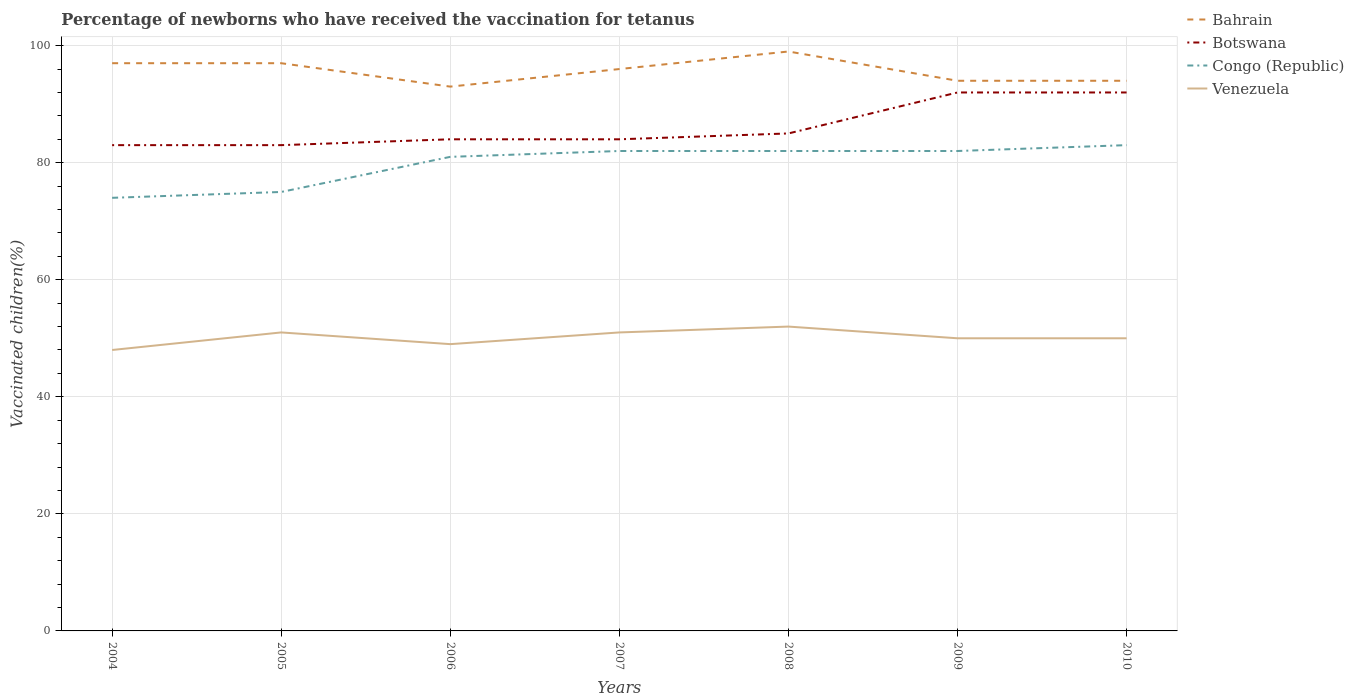Is the number of lines equal to the number of legend labels?
Offer a terse response. Yes. In which year was the percentage of vaccinated children in Venezuela maximum?
Give a very brief answer. 2004. What is the total percentage of vaccinated children in Congo (Republic) in the graph?
Make the answer very short. -8. What is the difference between the highest and the second highest percentage of vaccinated children in Botswana?
Offer a terse response. 9. How many lines are there?
Offer a terse response. 4. How many years are there in the graph?
Provide a short and direct response. 7. What is the difference between two consecutive major ticks on the Y-axis?
Provide a succinct answer. 20. Does the graph contain grids?
Your response must be concise. Yes. How many legend labels are there?
Ensure brevity in your answer.  4. What is the title of the graph?
Your response must be concise. Percentage of newborns who have received the vaccination for tetanus. What is the label or title of the X-axis?
Your response must be concise. Years. What is the label or title of the Y-axis?
Keep it short and to the point. Vaccinated children(%). What is the Vaccinated children(%) in Bahrain in 2004?
Provide a short and direct response. 97. What is the Vaccinated children(%) in Botswana in 2004?
Your answer should be compact. 83. What is the Vaccinated children(%) of Bahrain in 2005?
Ensure brevity in your answer.  97. What is the Vaccinated children(%) of Congo (Republic) in 2005?
Keep it short and to the point. 75. What is the Vaccinated children(%) of Bahrain in 2006?
Provide a succinct answer. 93. What is the Vaccinated children(%) of Congo (Republic) in 2006?
Make the answer very short. 81. What is the Vaccinated children(%) of Bahrain in 2007?
Your response must be concise. 96. What is the Vaccinated children(%) in Bahrain in 2008?
Your answer should be compact. 99. What is the Vaccinated children(%) of Botswana in 2008?
Give a very brief answer. 85. What is the Vaccinated children(%) in Bahrain in 2009?
Offer a terse response. 94. What is the Vaccinated children(%) in Botswana in 2009?
Give a very brief answer. 92. What is the Vaccinated children(%) in Congo (Republic) in 2009?
Make the answer very short. 82. What is the Vaccinated children(%) of Venezuela in 2009?
Offer a very short reply. 50. What is the Vaccinated children(%) of Bahrain in 2010?
Offer a terse response. 94. What is the Vaccinated children(%) of Botswana in 2010?
Provide a short and direct response. 92. Across all years, what is the maximum Vaccinated children(%) in Botswana?
Keep it short and to the point. 92. Across all years, what is the maximum Vaccinated children(%) in Congo (Republic)?
Offer a very short reply. 83. Across all years, what is the minimum Vaccinated children(%) of Bahrain?
Your answer should be compact. 93. Across all years, what is the minimum Vaccinated children(%) of Botswana?
Your response must be concise. 83. Across all years, what is the minimum Vaccinated children(%) of Venezuela?
Offer a very short reply. 48. What is the total Vaccinated children(%) in Bahrain in the graph?
Provide a succinct answer. 670. What is the total Vaccinated children(%) of Botswana in the graph?
Offer a very short reply. 603. What is the total Vaccinated children(%) of Congo (Republic) in the graph?
Offer a terse response. 559. What is the total Vaccinated children(%) of Venezuela in the graph?
Provide a succinct answer. 351. What is the difference between the Vaccinated children(%) of Congo (Republic) in 2004 and that in 2005?
Make the answer very short. -1. What is the difference between the Vaccinated children(%) of Venezuela in 2004 and that in 2006?
Ensure brevity in your answer.  -1. What is the difference between the Vaccinated children(%) in Venezuela in 2004 and that in 2007?
Your answer should be compact. -3. What is the difference between the Vaccinated children(%) in Botswana in 2004 and that in 2008?
Provide a short and direct response. -2. What is the difference between the Vaccinated children(%) in Venezuela in 2004 and that in 2008?
Your answer should be very brief. -4. What is the difference between the Vaccinated children(%) of Congo (Republic) in 2004 and that in 2009?
Ensure brevity in your answer.  -8. What is the difference between the Vaccinated children(%) of Botswana in 2004 and that in 2010?
Offer a very short reply. -9. What is the difference between the Vaccinated children(%) in Congo (Republic) in 2004 and that in 2010?
Make the answer very short. -9. What is the difference between the Vaccinated children(%) in Venezuela in 2004 and that in 2010?
Keep it short and to the point. -2. What is the difference between the Vaccinated children(%) of Congo (Republic) in 2005 and that in 2006?
Your response must be concise. -6. What is the difference between the Vaccinated children(%) in Bahrain in 2005 and that in 2007?
Ensure brevity in your answer.  1. What is the difference between the Vaccinated children(%) in Venezuela in 2005 and that in 2007?
Ensure brevity in your answer.  0. What is the difference between the Vaccinated children(%) of Botswana in 2005 and that in 2008?
Keep it short and to the point. -2. What is the difference between the Vaccinated children(%) in Congo (Republic) in 2005 and that in 2008?
Ensure brevity in your answer.  -7. What is the difference between the Vaccinated children(%) in Venezuela in 2005 and that in 2008?
Keep it short and to the point. -1. What is the difference between the Vaccinated children(%) of Bahrain in 2005 and that in 2009?
Your answer should be very brief. 3. What is the difference between the Vaccinated children(%) in Botswana in 2005 and that in 2009?
Your answer should be compact. -9. What is the difference between the Vaccinated children(%) of Bahrain in 2005 and that in 2010?
Offer a terse response. 3. What is the difference between the Vaccinated children(%) in Botswana in 2005 and that in 2010?
Make the answer very short. -9. What is the difference between the Vaccinated children(%) in Venezuela in 2005 and that in 2010?
Offer a very short reply. 1. What is the difference between the Vaccinated children(%) in Bahrain in 2006 and that in 2007?
Offer a terse response. -3. What is the difference between the Vaccinated children(%) in Botswana in 2006 and that in 2007?
Your answer should be very brief. 0. What is the difference between the Vaccinated children(%) in Venezuela in 2006 and that in 2007?
Offer a terse response. -2. What is the difference between the Vaccinated children(%) of Bahrain in 2006 and that in 2008?
Your answer should be very brief. -6. What is the difference between the Vaccinated children(%) of Venezuela in 2006 and that in 2009?
Your response must be concise. -1. What is the difference between the Vaccinated children(%) in Bahrain in 2006 and that in 2010?
Offer a very short reply. -1. What is the difference between the Vaccinated children(%) in Bahrain in 2007 and that in 2008?
Your answer should be compact. -3. What is the difference between the Vaccinated children(%) in Botswana in 2007 and that in 2008?
Your answer should be compact. -1. What is the difference between the Vaccinated children(%) of Congo (Republic) in 2007 and that in 2008?
Offer a terse response. 0. What is the difference between the Vaccinated children(%) in Venezuela in 2007 and that in 2008?
Make the answer very short. -1. What is the difference between the Vaccinated children(%) of Bahrain in 2007 and that in 2009?
Your response must be concise. 2. What is the difference between the Vaccinated children(%) in Congo (Republic) in 2007 and that in 2009?
Your answer should be very brief. 0. What is the difference between the Vaccinated children(%) of Bahrain in 2007 and that in 2010?
Provide a short and direct response. 2. What is the difference between the Vaccinated children(%) in Botswana in 2007 and that in 2010?
Your response must be concise. -8. What is the difference between the Vaccinated children(%) in Congo (Republic) in 2007 and that in 2010?
Make the answer very short. -1. What is the difference between the Vaccinated children(%) of Venezuela in 2007 and that in 2010?
Provide a short and direct response. 1. What is the difference between the Vaccinated children(%) of Venezuela in 2008 and that in 2009?
Ensure brevity in your answer.  2. What is the difference between the Vaccinated children(%) in Bahrain in 2008 and that in 2010?
Your response must be concise. 5. What is the difference between the Vaccinated children(%) of Botswana in 2008 and that in 2010?
Your answer should be very brief. -7. What is the difference between the Vaccinated children(%) of Botswana in 2009 and that in 2010?
Offer a terse response. 0. What is the difference between the Vaccinated children(%) of Congo (Republic) in 2009 and that in 2010?
Your answer should be compact. -1. What is the difference between the Vaccinated children(%) of Venezuela in 2009 and that in 2010?
Ensure brevity in your answer.  0. What is the difference between the Vaccinated children(%) in Bahrain in 2004 and the Vaccinated children(%) in Botswana in 2005?
Ensure brevity in your answer.  14. What is the difference between the Vaccinated children(%) of Bahrain in 2004 and the Vaccinated children(%) of Congo (Republic) in 2005?
Offer a very short reply. 22. What is the difference between the Vaccinated children(%) in Bahrain in 2004 and the Vaccinated children(%) in Botswana in 2006?
Your answer should be very brief. 13. What is the difference between the Vaccinated children(%) of Bahrain in 2004 and the Vaccinated children(%) of Venezuela in 2006?
Make the answer very short. 48. What is the difference between the Vaccinated children(%) in Botswana in 2004 and the Vaccinated children(%) in Congo (Republic) in 2006?
Give a very brief answer. 2. What is the difference between the Vaccinated children(%) of Congo (Republic) in 2004 and the Vaccinated children(%) of Venezuela in 2006?
Your answer should be very brief. 25. What is the difference between the Vaccinated children(%) in Bahrain in 2004 and the Vaccinated children(%) in Venezuela in 2007?
Provide a succinct answer. 46. What is the difference between the Vaccinated children(%) of Botswana in 2004 and the Vaccinated children(%) of Venezuela in 2007?
Your response must be concise. 32. What is the difference between the Vaccinated children(%) of Congo (Republic) in 2004 and the Vaccinated children(%) of Venezuela in 2007?
Offer a terse response. 23. What is the difference between the Vaccinated children(%) in Bahrain in 2004 and the Vaccinated children(%) in Botswana in 2008?
Keep it short and to the point. 12. What is the difference between the Vaccinated children(%) in Bahrain in 2004 and the Vaccinated children(%) in Congo (Republic) in 2008?
Offer a very short reply. 15. What is the difference between the Vaccinated children(%) of Bahrain in 2004 and the Vaccinated children(%) of Venezuela in 2008?
Make the answer very short. 45. What is the difference between the Vaccinated children(%) of Botswana in 2004 and the Vaccinated children(%) of Venezuela in 2008?
Your answer should be compact. 31. What is the difference between the Vaccinated children(%) in Bahrain in 2004 and the Vaccinated children(%) in Botswana in 2009?
Make the answer very short. 5. What is the difference between the Vaccinated children(%) in Bahrain in 2004 and the Vaccinated children(%) in Congo (Republic) in 2009?
Your response must be concise. 15. What is the difference between the Vaccinated children(%) of Congo (Republic) in 2004 and the Vaccinated children(%) of Venezuela in 2009?
Make the answer very short. 24. What is the difference between the Vaccinated children(%) in Botswana in 2004 and the Vaccinated children(%) in Congo (Republic) in 2010?
Keep it short and to the point. 0. What is the difference between the Vaccinated children(%) in Bahrain in 2005 and the Vaccinated children(%) in Botswana in 2007?
Give a very brief answer. 13. What is the difference between the Vaccinated children(%) of Bahrain in 2005 and the Vaccinated children(%) of Venezuela in 2007?
Your answer should be compact. 46. What is the difference between the Vaccinated children(%) in Botswana in 2005 and the Vaccinated children(%) in Congo (Republic) in 2007?
Offer a very short reply. 1. What is the difference between the Vaccinated children(%) in Bahrain in 2005 and the Vaccinated children(%) in Venezuela in 2008?
Make the answer very short. 45. What is the difference between the Vaccinated children(%) in Botswana in 2005 and the Vaccinated children(%) in Congo (Republic) in 2008?
Give a very brief answer. 1. What is the difference between the Vaccinated children(%) of Bahrain in 2005 and the Vaccinated children(%) of Venezuela in 2009?
Ensure brevity in your answer.  47. What is the difference between the Vaccinated children(%) in Botswana in 2005 and the Vaccinated children(%) in Venezuela in 2009?
Your answer should be compact. 33. What is the difference between the Vaccinated children(%) of Congo (Republic) in 2005 and the Vaccinated children(%) of Venezuela in 2009?
Provide a short and direct response. 25. What is the difference between the Vaccinated children(%) in Bahrain in 2005 and the Vaccinated children(%) in Congo (Republic) in 2010?
Give a very brief answer. 14. What is the difference between the Vaccinated children(%) of Botswana in 2005 and the Vaccinated children(%) of Congo (Republic) in 2010?
Provide a short and direct response. 0. What is the difference between the Vaccinated children(%) of Bahrain in 2006 and the Vaccinated children(%) of Botswana in 2007?
Provide a short and direct response. 9. What is the difference between the Vaccinated children(%) in Bahrain in 2006 and the Vaccinated children(%) in Congo (Republic) in 2007?
Make the answer very short. 11. What is the difference between the Vaccinated children(%) in Bahrain in 2006 and the Vaccinated children(%) in Venezuela in 2007?
Offer a terse response. 42. What is the difference between the Vaccinated children(%) in Bahrain in 2006 and the Vaccinated children(%) in Botswana in 2008?
Your answer should be very brief. 8. What is the difference between the Vaccinated children(%) of Bahrain in 2006 and the Vaccinated children(%) of Venezuela in 2008?
Provide a succinct answer. 41. What is the difference between the Vaccinated children(%) in Botswana in 2006 and the Vaccinated children(%) in Congo (Republic) in 2008?
Keep it short and to the point. 2. What is the difference between the Vaccinated children(%) of Bahrain in 2006 and the Vaccinated children(%) of Botswana in 2009?
Provide a short and direct response. 1. What is the difference between the Vaccinated children(%) of Botswana in 2006 and the Vaccinated children(%) of Congo (Republic) in 2009?
Provide a short and direct response. 2. What is the difference between the Vaccinated children(%) in Botswana in 2006 and the Vaccinated children(%) in Venezuela in 2009?
Keep it short and to the point. 34. What is the difference between the Vaccinated children(%) of Congo (Republic) in 2006 and the Vaccinated children(%) of Venezuela in 2009?
Give a very brief answer. 31. What is the difference between the Vaccinated children(%) in Bahrain in 2006 and the Vaccinated children(%) in Botswana in 2010?
Keep it short and to the point. 1. What is the difference between the Vaccinated children(%) in Bahrain in 2006 and the Vaccinated children(%) in Congo (Republic) in 2010?
Your answer should be very brief. 10. What is the difference between the Vaccinated children(%) of Bahrain in 2006 and the Vaccinated children(%) of Venezuela in 2010?
Your answer should be compact. 43. What is the difference between the Vaccinated children(%) of Botswana in 2006 and the Vaccinated children(%) of Venezuela in 2010?
Your answer should be very brief. 34. What is the difference between the Vaccinated children(%) of Congo (Republic) in 2006 and the Vaccinated children(%) of Venezuela in 2010?
Ensure brevity in your answer.  31. What is the difference between the Vaccinated children(%) in Botswana in 2007 and the Vaccinated children(%) in Venezuela in 2008?
Provide a succinct answer. 32. What is the difference between the Vaccinated children(%) in Congo (Republic) in 2007 and the Vaccinated children(%) in Venezuela in 2008?
Provide a succinct answer. 30. What is the difference between the Vaccinated children(%) in Bahrain in 2007 and the Vaccinated children(%) in Botswana in 2009?
Your answer should be very brief. 4. What is the difference between the Vaccinated children(%) of Bahrain in 2007 and the Vaccinated children(%) of Congo (Republic) in 2009?
Give a very brief answer. 14. What is the difference between the Vaccinated children(%) of Bahrain in 2007 and the Vaccinated children(%) of Venezuela in 2009?
Offer a very short reply. 46. What is the difference between the Vaccinated children(%) in Bahrain in 2007 and the Vaccinated children(%) in Congo (Republic) in 2010?
Give a very brief answer. 13. What is the difference between the Vaccinated children(%) in Bahrain in 2007 and the Vaccinated children(%) in Venezuela in 2010?
Your answer should be very brief. 46. What is the difference between the Vaccinated children(%) of Botswana in 2007 and the Vaccinated children(%) of Congo (Republic) in 2010?
Your response must be concise. 1. What is the difference between the Vaccinated children(%) of Congo (Republic) in 2007 and the Vaccinated children(%) of Venezuela in 2010?
Your answer should be very brief. 32. What is the difference between the Vaccinated children(%) of Bahrain in 2008 and the Vaccinated children(%) of Botswana in 2009?
Offer a very short reply. 7. What is the difference between the Vaccinated children(%) in Bahrain in 2008 and the Vaccinated children(%) in Venezuela in 2009?
Make the answer very short. 49. What is the difference between the Vaccinated children(%) of Botswana in 2008 and the Vaccinated children(%) of Congo (Republic) in 2009?
Ensure brevity in your answer.  3. What is the difference between the Vaccinated children(%) in Bahrain in 2008 and the Vaccinated children(%) in Congo (Republic) in 2010?
Offer a terse response. 16. What is the difference between the Vaccinated children(%) in Bahrain in 2008 and the Vaccinated children(%) in Venezuela in 2010?
Provide a short and direct response. 49. What is the difference between the Vaccinated children(%) of Botswana in 2008 and the Vaccinated children(%) of Congo (Republic) in 2010?
Offer a terse response. 2. What is the difference between the Vaccinated children(%) in Botswana in 2008 and the Vaccinated children(%) in Venezuela in 2010?
Your answer should be very brief. 35. What is the difference between the Vaccinated children(%) in Congo (Republic) in 2008 and the Vaccinated children(%) in Venezuela in 2010?
Offer a terse response. 32. What is the difference between the Vaccinated children(%) in Bahrain in 2009 and the Vaccinated children(%) in Botswana in 2010?
Provide a short and direct response. 2. What is the difference between the Vaccinated children(%) in Bahrain in 2009 and the Vaccinated children(%) in Venezuela in 2010?
Your answer should be compact. 44. What is the difference between the Vaccinated children(%) of Botswana in 2009 and the Vaccinated children(%) of Congo (Republic) in 2010?
Ensure brevity in your answer.  9. What is the difference between the Vaccinated children(%) of Botswana in 2009 and the Vaccinated children(%) of Venezuela in 2010?
Keep it short and to the point. 42. What is the average Vaccinated children(%) in Bahrain per year?
Provide a succinct answer. 95.71. What is the average Vaccinated children(%) of Botswana per year?
Give a very brief answer. 86.14. What is the average Vaccinated children(%) of Congo (Republic) per year?
Ensure brevity in your answer.  79.86. What is the average Vaccinated children(%) in Venezuela per year?
Provide a succinct answer. 50.14. In the year 2004, what is the difference between the Vaccinated children(%) in Bahrain and Vaccinated children(%) in Congo (Republic)?
Offer a very short reply. 23. In the year 2004, what is the difference between the Vaccinated children(%) in Botswana and Vaccinated children(%) in Congo (Republic)?
Give a very brief answer. 9. In the year 2005, what is the difference between the Vaccinated children(%) in Bahrain and Vaccinated children(%) in Botswana?
Give a very brief answer. 14. In the year 2005, what is the difference between the Vaccinated children(%) in Bahrain and Vaccinated children(%) in Congo (Republic)?
Ensure brevity in your answer.  22. In the year 2005, what is the difference between the Vaccinated children(%) of Bahrain and Vaccinated children(%) of Venezuela?
Your answer should be very brief. 46. In the year 2005, what is the difference between the Vaccinated children(%) of Congo (Republic) and Vaccinated children(%) of Venezuela?
Provide a short and direct response. 24. In the year 2006, what is the difference between the Vaccinated children(%) of Bahrain and Vaccinated children(%) of Botswana?
Your response must be concise. 9. In the year 2006, what is the difference between the Vaccinated children(%) in Bahrain and Vaccinated children(%) in Venezuela?
Keep it short and to the point. 44. In the year 2006, what is the difference between the Vaccinated children(%) in Botswana and Vaccinated children(%) in Congo (Republic)?
Ensure brevity in your answer.  3. In the year 2006, what is the difference between the Vaccinated children(%) of Botswana and Vaccinated children(%) of Venezuela?
Make the answer very short. 35. In the year 2006, what is the difference between the Vaccinated children(%) of Congo (Republic) and Vaccinated children(%) of Venezuela?
Give a very brief answer. 32. In the year 2007, what is the difference between the Vaccinated children(%) of Bahrain and Vaccinated children(%) of Botswana?
Your answer should be compact. 12. In the year 2007, what is the difference between the Vaccinated children(%) of Bahrain and Vaccinated children(%) of Congo (Republic)?
Keep it short and to the point. 14. In the year 2007, what is the difference between the Vaccinated children(%) of Bahrain and Vaccinated children(%) of Venezuela?
Make the answer very short. 45. In the year 2007, what is the difference between the Vaccinated children(%) in Congo (Republic) and Vaccinated children(%) in Venezuela?
Offer a terse response. 31. In the year 2008, what is the difference between the Vaccinated children(%) in Bahrain and Vaccinated children(%) in Botswana?
Keep it short and to the point. 14. In the year 2008, what is the difference between the Vaccinated children(%) of Bahrain and Vaccinated children(%) of Congo (Republic)?
Your answer should be very brief. 17. In the year 2008, what is the difference between the Vaccinated children(%) of Bahrain and Vaccinated children(%) of Venezuela?
Your answer should be very brief. 47. In the year 2008, what is the difference between the Vaccinated children(%) in Botswana and Vaccinated children(%) in Congo (Republic)?
Ensure brevity in your answer.  3. In the year 2008, what is the difference between the Vaccinated children(%) of Botswana and Vaccinated children(%) of Venezuela?
Offer a terse response. 33. In the year 2009, what is the difference between the Vaccinated children(%) of Botswana and Vaccinated children(%) of Congo (Republic)?
Your answer should be very brief. 10. In the year 2009, what is the difference between the Vaccinated children(%) of Congo (Republic) and Vaccinated children(%) of Venezuela?
Offer a very short reply. 32. In the year 2010, what is the difference between the Vaccinated children(%) in Bahrain and Vaccinated children(%) in Botswana?
Your response must be concise. 2. In the year 2010, what is the difference between the Vaccinated children(%) of Bahrain and Vaccinated children(%) of Venezuela?
Your answer should be compact. 44. What is the ratio of the Vaccinated children(%) of Bahrain in 2004 to that in 2005?
Offer a very short reply. 1. What is the ratio of the Vaccinated children(%) of Congo (Republic) in 2004 to that in 2005?
Your answer should be compact. 0.99. What is the ratio of the Vaccinated children(%) of Bahrain in 2004 to that in 2006?
Make the answer very short. 1.04. What is the ratio of the Vaccinated children(%) in Congo (Republic) in 2004 to that in 2006?
Offer a very short reply. 0.91. What is the ratio of the Vaccinated children(%) of Venezuela in 2004 to that in 2006?
Provide a succinct answer. 0.98. What is the ratio of the Vaccinated children(%) in Bahrain in 2004 to that in 2007?
Offer a terse response. 1.01. What is the ratio of the Vaccinated children(%) of Congo (Republic) in 2004 to that in 2007?
Provide a succinct answer. 0.9. What is the ratio of the Vaccinated children(%) in Venezuela in 2004 to that in 2007?
Give a very brief answer. 0.94. What is the ratio of the Vaccinated children(%) of Bahrain in 2004 to that in 2008?
Your response must be concise. 0.98. What is the ratio of the Vaccinated children(%) of Botswana in 2004 to that in 2008?
Your answer should be very brief. 0.98. What is the ratio of the Vaccinated children(%) in Congo (Republic) in 2004 to that in 2008?
Provide a succinct answer. 0.9. What is the ratio of the Vaccinated children(%) in Venezuela in 2004 to that in 2008?
Offer a terse response. 0.92. What is the ratio of the Vaccinated children(%) in Bahrain in 2004 to that in 2009?
Ensure brevity in your answer.  1.03. What is the ratio of the Vaccinated children(%) in Botswana in 2004 to that in 2009?
Make the answer very short. 0.9. What is the ratio of the Vaccinated children(%) in Congo (Republic) in 2004 to that in 2009?
Keep it short and to the point. 0.9. What is the ratio of the Vaccinated children(%) in Venezuela in 2004 to that in 2009?
Keep it short and to the point. 0.96. What is the ratio of the Vaccinated children(%) of Bahrain in 2004 to that in 2010?
Make the answer very short. 1.03. What is the ratio of the Vaccinated children(%) in Botswana in 2004 to that in 2010?
Your answer should be compact. 0.9. What is the ratio of the Vaccinated children(%) of Congo (Republic) in 2004 to that in 2010?
Offer a very short reply. 0.89. What is the ratio of the Vaccinated children(%) in Bahrain in 2005 to that in 2006?
Offer a very short reply. 1.04. What is the ratio of the Vaccinated children(%) of Botswana in 2005 to that in 2006?
Your response must be concise. 0.99. What is the ratio of the Vaccinated children(%) in Congo (Republic) in 2005 to that in 2006?
Offer a terse response. 0.93. What is the ratio of the Vaccinated children(%) of Venezuela in 2005 to that in 2006?
Give a very brief answer. 1.04. What is the ratio of the Vaccinated children(%) of Bahrain in 2005 to that in 2007?
Your response must be concise. 1.01. What is the ratio of the Vaccinated children(%) of Congo (Republic) in 2005 to that in 2007?
Your answer should be very brief. 0.91. What is the ratio of the Vaccinated children(%) in Bahrain in 2005 to that in 2008?
Provide a succinct answer. 0.98. What is the ratio of the Vaccinated children(%) of Botswana in 2005 to that in 2008?
Ensure brevity in your answer.  0.98. What is the ratio of the Vaccinated children(%) in Congo (Republic) in 2005 to that in 2008?
Your response must be concise. 0.91. What is the ratio of the Vaccinated children(%) in Venezuela in 2005 to that in 2008?
Provide a short and direct response. 0.98. What is the ratio of the Vaccinated children(%) in Bahrain in 2005 to that in 2009?
Provide a short and direct response. 1.03. What is the ratio of the Vaccinated children(%) of Botswana in 2005 to that in 2009?
Offer a terse response. 0.9. What is the ratio of the Vaccinated children(%) in Congo (Republic) in 2005 to that in 2009?
Your answer should be very brief. 0.91. What is the ratio of the Vaccinated children(%) of Bahrain in 2005 to that in 2010?
Make the answer very short. 1.03. What is the ratio of the Vaccinated children(%) in Botswana in 2005 to that in 2010?
Your response must be concise. 0.9. What is the ratio of the Vaccinated children(%) of Congo (Republic) in 2005 to that in 2010?
Your answer should be compact. 0.9. What is the ratio of the Vaccinated children(%) in Venezuela in 2005 to that in 2010?
Give a very brief answer. 1.02. What is the ratio of the Vaccinated children(%) of Bahrain in 2006 to that in 2007?
Ensure brevity in your answer.  0.97. What is the ratio of the Vaccinated children(%) of Botswana in 2006 to that in 2007?
Make the answer very short. 1. What is the ratio of the Vaccinated children(%) in Congo (Republic) in 2006 to that in 2007?
Keep it short and to the point. 0.99. What is the ratio of the Vaccinated children(%) in Venezuela in 2006 to that in 2007?
Offer a very short reply. 0.96. What is the ratio of the Vaccinated children(%) of Bahrain in 2006 to that in 2008?
Keep it short and to the point. 0.94. What is the ratio of the Vaccinated children(%) in Congo (Republic) in 2006 to that in 2008?
Offer a very short reply. 0.99. What is the ratio of the Vaccinated children(%) of Venezuela in 2006 to that in 2008?
Your answer should be very brief. 0.94. What is the ratio of the Vaccinated children(%) in Congo (Republic) in 2006 to that in 2010?
Offer a terse response. 0.98. What is the ratio of the Vaccinated children(%) of Bahrain in 2007 to that in 2008?
Offer a very short reply. 0.97. What is the ratio of the Vaccinated children(%) of Botswana in 2007 to that in 2008?
Give a very brief answer. 0.99. What is the ratio of the Vaccinated children(%) in Venezuela in 2007 to that in 2008?
Give a very brief answer. 0.98. What is the ratio of the Vaccinated children(%) in Bahrain in 2007 to that in 2009?
Provide a succinct answer. 1.02. What is the ratio of the Vaccinated children(%) in Venezuela in 2007 to that in 2009?
Keep it short and to the point. 1.02. What is the ratio of the Vaccinated children(%) of Bahrain in 2007 to that in 2010?
Provide a succinct answer. 1.02. What is the ratio of the Vaccinated children(%) in Venezuela in 2007 to that in 2010?
Your answer should be very brief. 1.02. What is the ratio of the Vaccinated children(%) in Bahrain in 2008 to that in 2009?
Offer a very short reply. 1.05. What is the ratio of the Vaccinated children(%) of Botswana in 2008 to that in 2009?
Offer a very short reply. 0.92. What is the ratio of the Vaccinated children(%) of Venezuela in 2008 to that in 2009?
Your answer should be very brief. 1.04. What is the ratio of the Vaccinated children(%) in Bahrain in 2008 to that in 2010?
Keep it short and to the point. 1.05. What is the ratio of the Vaccinated children(%) of Botswana in 2008 to that in 2010?
Make the answer very short. 0.92. What is the ratio of the Vaccinated children(%) in Botswana in 2009 to that in 2010?
Ensure brevity in your answer.  1. What is the ratio of the Vaccinated children(%) of Venezuela in 2009 to that in 2010?
Provide a short and direct response. 1. What is the difference between the highest and the second highest Vaccinated children(%) in Bahrain?
Make the answer very short. 2. What is the difference between the highest and the second highest Vaccinated children(%) in Botswana?
Your response must be concise. 0. What is the difference between the highest and the lowest Vaccinated children(%) in Bahrain?
Provide a succinct answer. 6. What is the difference between the highest and the lowest Vaccinated children(%) in Venezuela?
Provide a succinct answer. 4. 